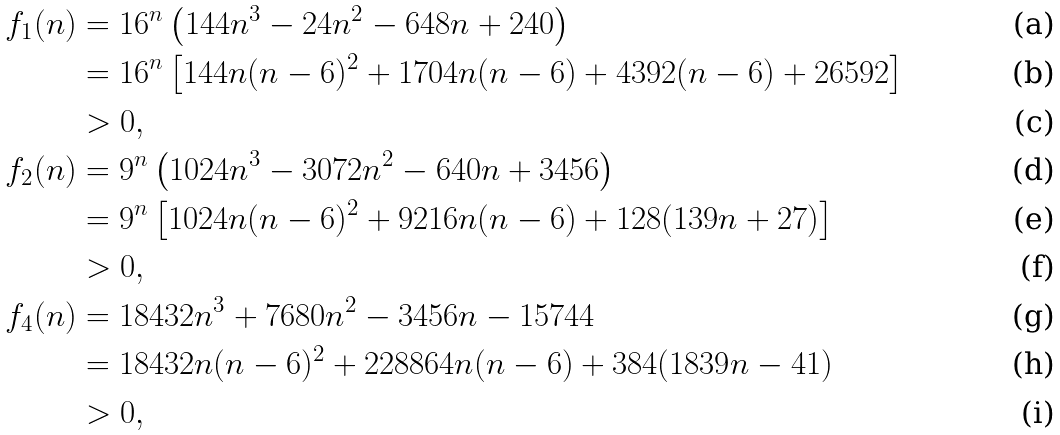Convert formula to latex. <formula><loc_0><loc_0><loc_500><loc_500>f _ { 1 } ( n ) & = 1 6 ^ { n } \left ( 1 4 4 n ^ { 3 } - 2 4 n ^ { 2 } - 6 4 8 n + 2 4 0 \right ) \\ & = 1 6 ^ { n } \left [ 1 4 4 n ( n - 6 ) ^ { 2 } + 1 7 0 4 n ( n - 6 ) + 4 3 9 2 ( n - 6 ) + 2 6 5 9 2 \right ] \\ & > 0 , \\ f _ { 2 } ( n ) & = 9 ^ { n } \left ( 1 0 2 4 n ^ { 3 } - 3 0 7 2 n ^ { 2 } - 6 4 0 n + 3 4 5 6 \right ) \\ & = 9 ^ { n } \left [ 1 0 2 4 n ( n - 6 ) ^ { 2 } + 9 2 1 6 n ( n - 6 ) + 1 2 8 ( 1 3 9 n + 2 7 ) \right ] \\ & > 0 , \\ f _ { 4 } ( n ) & = 1 8 4 3 2 n ^ { 3 } + 7 6 8 0 n ^ { 2 } - 3 4 5 6 n - 1 5 7 4 4 \\ & = 1 8 4 3 2 n ( n - 6 ) ^ { 2 } + 2 2 8 8 6 4 n ( n - 6 ) + 3 8 4 ( 1 8 3 9 n - 4 1 ) \\ & > 0 ,</formula> 